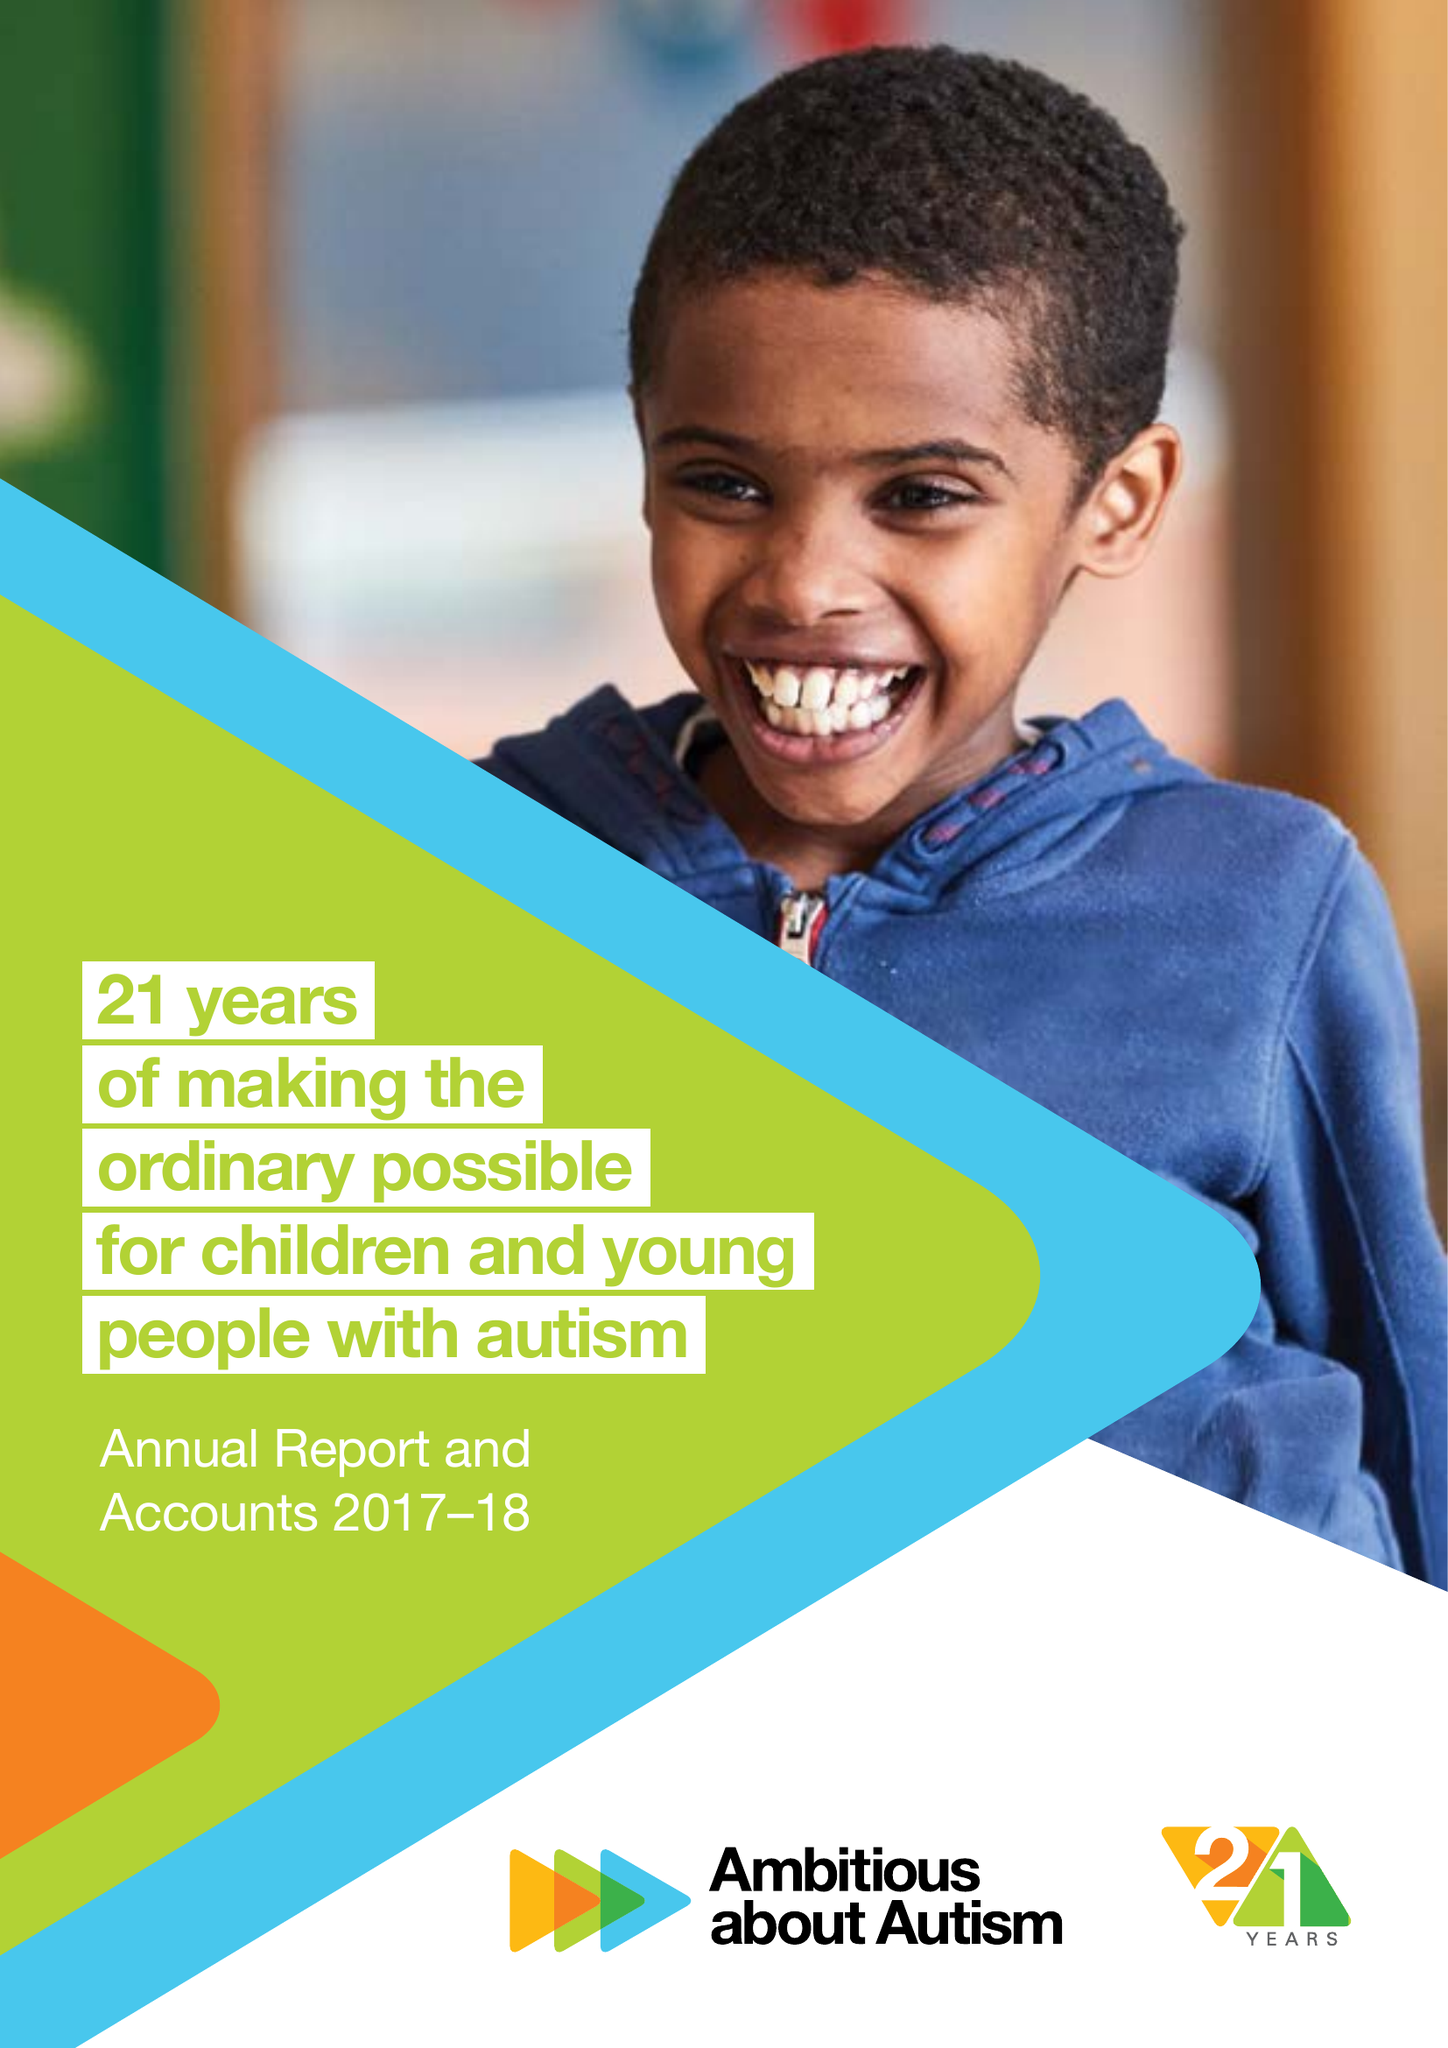What is the value for the charity_number?
Answer the question using a single word or phrase. 1063184 